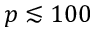<formula> <loc_0><loc_0><loc_500><loc_500>p \lesssim 1 0 0</formula> 